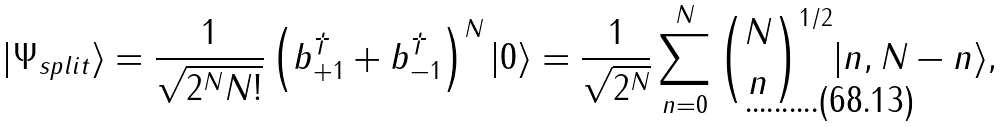Convert formula to latex. <formula><loc_0><loc_0><loc_500><loc_500>| \Psi _ { s p l i t } \rangle = \frac { 1 } { \sqrt { 2 ^ { N } N ! } } \left ( b ^ { \dagger } _ { + 1 } + b ^ { \dagger } _ { - 1 } \right ) ^ { N } | 0 \rangle = \frac { 1 } { \sqrt { 2 ^ { N } } } \sum _ { n = 0 } ^ { N } \binom { N } { n } ^ { 1 / 2 } | n , N - n \rangle ,</formula> 